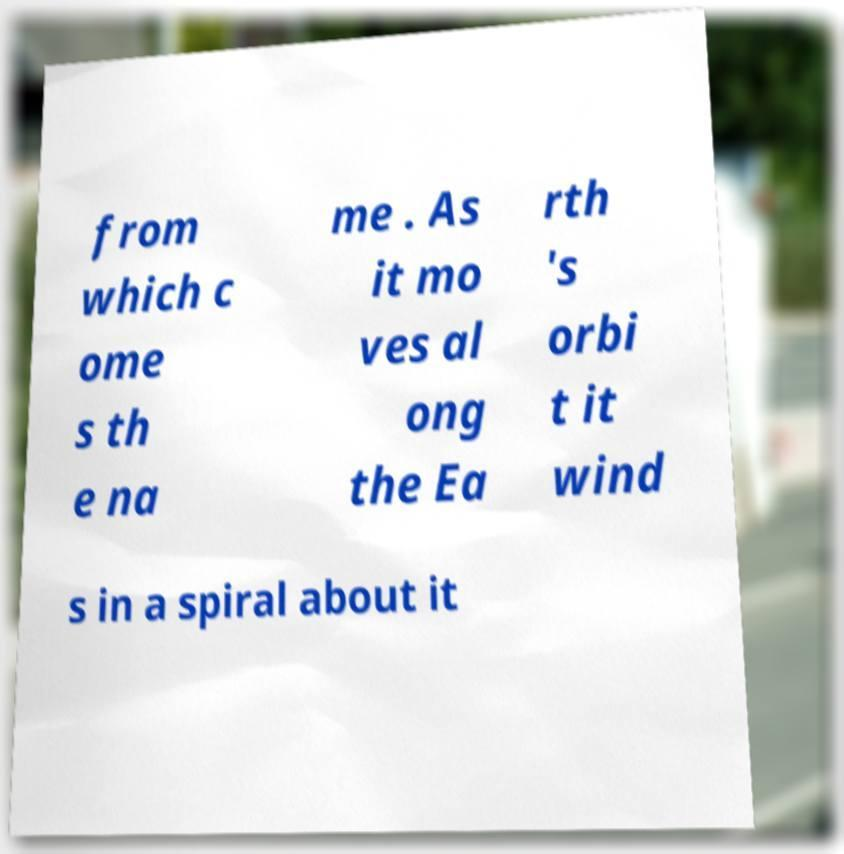There's text embedded in this image that I need extracted. Can you transcribe it verbatim? from which c ome s th e na me . As it mo ves al ong the Ea rth 's orbi t it wind s in a spiral about it 